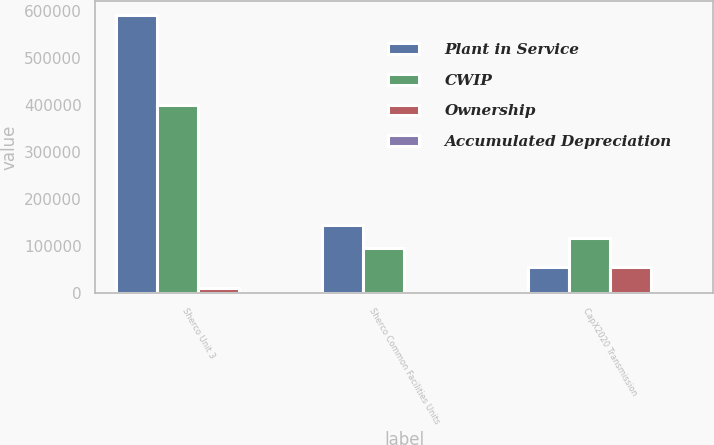<chart> <loc_0><loc_0><loc_500><loc_500><stacked_bar_chart><ecel><fcel>Sherco Unit 3<fcel>Sherco Common Facilities Units<fcel>CapX2020 Transmission<nl><fcel>Plant in Service<fcel>589903<fcel>145447<fcel>56024<nl><fcel>CWIP<fcel>398367<fcel>95909<fcel>116942<nl><fcel>Ownership<fcel>9714<fcel>540<fcel>56024<nl><fcel>Accumulated Depreciation<fcel>59<fcel>80<fcel>51<nl></chart> 